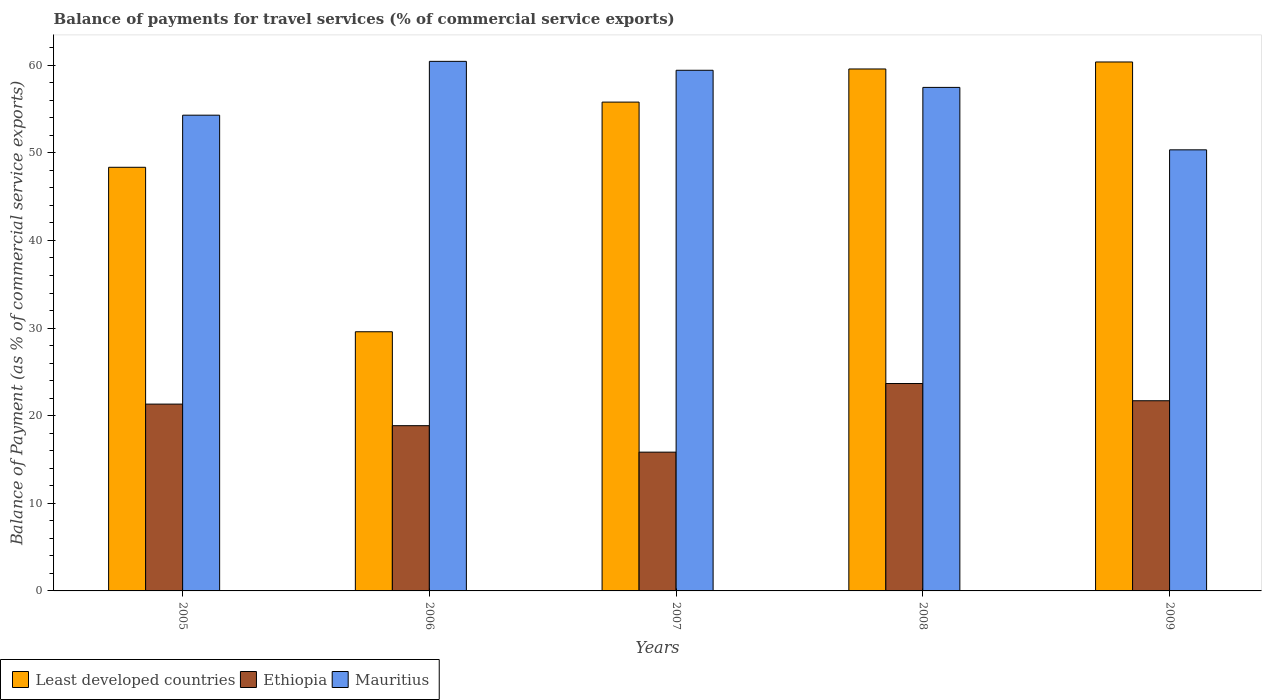How many different coloured bars are there?
Ensure brevity in your answer.  3. How many groups of bars are there?
Your answer should be very brief. 5. Are the number of bars on each tick of the X-axis equal?
Offer a very short reply. Yes. How many bars are there on the 2nd tick from the right?
Ensure brevity in your answer.  3. What is the label of the 2nd group of bars from the left?
Provide a short and direct response. 2006. In how many cases, is the number of bars for a given year not equal to the number of legend labels?
Offer a terse response. 0. What is the balance of payments for travel services in Least developed countries in 2008?
Provide a succinct answer. 59.57. Across all years, what is the maximum balance of payments for travel services in Least developed countries?
Give a very brief answer. 60.37. Across all years, what is the minimum balance of payments for travel services in Mauritius?
Make the answer very short. 50.34. In which year was the balance of payments for travel services in Least developed countries maximum?
Your answer should be compact. 2009. What is the total balance of payments for travel services in Mauritius in the graph?
Make the answer very short. 281.98. What is the difference between the balance of payments for travel services in Least developed countries in 2005 and that in 2008?
Keep it short and to the point. -11.22. What is the difference between the balance of payments for travel services in Least developed countries in 2007 and the balance of payments for travel services in Ethiopia in 2008?
Offer a terse response. 32.12. What is the average balance of payments for travel services in Ethiopia per year?
Offer a very short reply. 20.28. In the year 2009, what is the difference between the balance of payments for travel services in Ethiopia and balance of payments for travel services in Least developed countries?
Your answer should be very brief. -38.67. What is the ratio of the balance of payments for travel services in Ethiopia in 2008 to that in 2009?
Your answer should be very brief. 1.09. Is the difference between the balance of payments for travel services in Ethiopia in 2005 and 2009 greater than the difference between the balance of payments for travel services in Least developed countries in 2005 and 2009?
Give a very brief answer. Yes. What is the difference between the highest and the second highest balance of payments for travel services in Ethiopia?
Ensure brevity in your answer.  1.97. What is the difference between the highest and the lowest balance of payments for travel services in Ethiopia?
Keep it short and to the point. 7.83. Is the sum of the balance of payments for travel services in Least developed countries in 2005 and 2007 greater than the maximum balance of payments for travel services in Mauritius across all years?
Make the answer very short. Yes. What does the 3rd bar from the left in 2005 represents?
Offer a terse response. Mauritius. What does the 1st bar from the right in 2006 represents?
Make the answer very short. Mauritius. How many bars are there?
Keep it short and to the point. 15. How many years are there in the graph?
Your answer should be very brief. 5. Does the graph contain grids?
Ensure brevity in your answer.  No. Where does the legend appear in the graph?
Provide a succinct answer. Bottom left. How many legend labels are there?
Make the answer very short. 3. How are the legend labels stacked?
Provide a succinct answer. Horizontal. What is the title of the graph?
Offer a very short reply. Balance of payments for travel services (% of commercial service exports). What is the label or title of the Y-axis?
Your response must be concise. Balance of Payment (as % of commercial service exports). What is the Balance of Payment (as % of commercial service exports) in Least developed countries in 2005?
Ensure brevity in your answer.  48.35. What is the Balance of Payment (as % of commercial service exports) of Ethiopia in 2005?
Ensure brevity in your answer.  21.32. What is the Balance of Payment (as % of commercial service exports) of Mauritius in 2005?
Give a very brief answer. 54.3. What is the Balance of Payment (as % of commercial service exports) of Least developed countries in 2006?
Offer a very short reply. 29.58. What is the Balance of Payment (as % of commercial service exports) in Ethiopia in 2006?
Offer a very short reply. 18.86. What is the Balance of Payment (as % of commercial service exports) of Mauritius in 2006?
Provide a succinct answer. 60.44. What is the Balance of Payment (as % of commercial service exports) in Least developed countries in 2007?
Provide a succinct answer. 55.79. What is the Balance of Payment (as % of commercial service exports) of Ethiopia in 2007?
Your answer should be compact. 15.84. What is the Balance of Payment (as % of commercial service exports) of Mauritius in 2007?
Offer a very short reply. 59.42. What is the Balance of Payment (as % of commercial service exports) of Least developed countries in 2008?
Keep it short and to the point. 59.57. What is the Balance of Payment (as % of commercial service exports) in Ethiopia in 2008?
Ensure brevity in your answer.  23.67. What is the Balance of Payment (as % of commercial service exports) of Mauritius in 2008?
Provide a succinct answer. 57.47. What is the Balance of Payment (as % of commercial service exports) of Least developed countries in 2009?
Keep it short and to the point. 60.37. What is the Balance of Payment (as % of commercial service exports) of Ethiopia in 2009?
Ensure brevity in your answer.  21.71. What is the Balance of Payment (as % of commercial service exports) in Mauritius in 2009?
Offer a terse response. 50.34. Across all years, what is the maximum Balance of Payment (as % of commercial service exports) in Least developed countries?
Your response must be concise. 60.37. Across all years, what is the maximum Balance of Payment (as % of commercial service exports) in Ethiopia?
Provide a succinct answer. 23.67. Across all years, what is the maximum Balance of Payment (as % of commercial service exports) in Mauritius?
Your answer should be very brief. 60.44. Across all years, what is the minimum Balance of Payment (as % of commercial service exports) of Least developed countries?
Provide a short and direct response. 29.58. Across all years, what is the minimum Balance of Payment (as % of commercial service exports) in Ethiopia?
Keep it short and to the point. 15.84. Across all years, what is the minimum Balance of Payment (as % of commercial service exports) of Mauritius?
Make the answer very short. 50.34. What is the total Balance of Payment (as % of commercial service exports) of Least developed countries in the graph?
Keep it short and to the point. 253.67. What is the total Balance of Payment (as % of commercial service exports) of Ethiopia in the graph?
Your response must be concise. 101.4. What is the total Balance of Payment (as % of commercial service exports) in Mauritius in the graph?
Keep it short and to the point. 281.98. What is the difference between the Balance of Payment (as % of commercial service exports) in Least developed countries in 2005 and that in 2006?
Your answer should be very brief. 18.77. What is the difference between the Balance of Payment (as % of commercial service exports) in Ethiopia in 2005 and that in 2006?
Make the answer very short. 2.46. What is the difference between the Balance of Payment (as % of commercial service exports) of Mauritius in 2005 and that in 2006?
Give a very brief answer. -6.14. What is the difference between the Balance of Payment (as % of commercial service exports) in Least developed countries in 2005 and that in 2007?
Offer a very short reply. -7.44. What is the difference between the Balance of Payment (as % of commercial service exports) in Ethiopia in 2005 and that in 2007?
Offer a terse response. 5.48. What is the difference between the Balance of Payment (as % of commercial service exports) in Mauritius in 2005 and that in 2007?
Give a very brief answer. -5.13. What is the difference between the Balance of Payment (as % of commercial service exports) of Least developed countries in 2005 and that in 2008?
Make the answer very short. -11.22. What is the difference between the Balance of Payment (as % of commercial service exports) of Ethiopia in 2005 and that in 2008?
Ensure brevity in your answer.  -2.35. What is the difference between the Balance of Payment (as % of commercial service exports) of Mauritius in 2005 and that in 2008?
Make the answer very short. -3.17. What is the difference between the Balance of Payment (as % of commercial service exports) in Least developed countries in 2005 and that in 2009?
Your answer should be very brief. -12.02. What is the difference between the Balance of Payment (as % of commercial service exports) in Ethiopia in 2005 and that in 2009?
Make the answer very short. -0.38. What is the difference between the Balance of Payment (as % of commercial service exports) of Mauritius in 2005 and that in 2009?
Make the answer very short. 3.95. What is the difference between the Balance of Payment (as % of commercial service exports) of Least developed countries in 2006 and that in 2007?
Give a very brief answer. -26.21. What is the difference between the Balance of Payment (as % of commercial service exports) of Ethiopia in 2006 and that in 2007?
Your response must be concise. 3.02. What is the difference between the Balance of Payment (as % of commercial service exports) of Mauritius in 2006 and that in 2007?
Ensure brevity in your answer.  1.02. What is the difference between the Balance of Payment (as % of commercial service exports) of Least developed countries in 2006 and that in 2008?
Offer a terse response. -29.99. What is the difference between the Balance of Payment (as % of commercial service exports) in Ethiopia in 2006 and that in 2008?
Offer a terse response. -4.81. What is the difference between the Balance of Payment (as % of commercial service exports) in Mauritius in 2006 and that in 2008?
Offer a terse response. 2.97. What is the difference between the Balance of Payment (as % of commercial service exports) of Least developed countries in 2006 and that in 2009?
Make the answer very short. -30.79. What is the difference between the Balance of Payment (as % of commercial service exports) of Ethiopia in 2006 and that in 2009?
Ensure brevity in your answer.  -2.85. What is the difference between the Balance of Payment (as % of commercial service exports) of Mauritius in 2006 and that in 2009?
Give a very brief answer. 10.1. What is the difference between the Balance of Payment (as % of commercial service exports) of Least developed countries in 2007 and that in 2008?
Your answer should be compact. -3.78. What is the difference between the Balance of Payment (as % of commercial service exports) in Ethiopia in 2007 and that in 2008?
Provide a succinct answer. -7.83. What is the difference between the Balance of Payment (as % of commercial service exports) of Mauritius in 2007 and that in 2008?
Your answer should be compact. 1.95. What is the difference between the Balance of Payment (as % of commercial service exports) of Least developed countries in 2007 and that in 2009?
Make the answer very short. -4.58. What is the difference between the Balance of Payment (as % of commercial service exports) of Ethiopia in 2007 and that in 2009?
Provide a succinct answer. -5.87. What is the difference between the Balance of Payment (as % of commercial service exports) in Mauritius in 2007 and that in 2009?
Give a very brief answer. 9.08. What is the difference between the Balance of Payment (as % of commercial service exports) in Least developed countries in 2008 and that in 2009?
Make the answer very short. -0.8. What is the difference between the Balance of Payment (as % of commercial service exports) in Ethiopia in 2008 and that in 2009?
Your response must be concise. 1.97. What is the difference between the Balance of Payment (as % of commercial service exports) of Mauritius in 2008 and that in 2009?
Your answer should be very brief. 7.13. What is the difference between the Balance of Payment (as % of commercial service exports) in Least developed countries in 2005 and the Balance of Payment (as % of commercial service exports) in Ethiopia in 2006?
Your answer should be very brief. 29.49. What is the difference between the Balance of Payment (as % of commercial service exports) of Least developed countries in 2005 and the Balance of Payment (as % of commercial service exports) of Mauritius in 2006?
Your response must be concise. -12.09. What is the difference between the Balance of Payment (as % of commercial service exports) in Ethiopia in 2005 and the Balance of Payment (as % of commercial service exports) in Mauritius in 2006?
Ensure brevity in your answer.  -39.12. What is the difference between the Balance of Payment (as % of commercial service exports) of Least developed countries in 2005 and the Balance of Payment (as % of commercial service exports) of Ethiopia in 2007?
Your response must be concise. 32.51. What is the difference between the Balance of Payment (as % of commercial service exports) in Least developed countries in 2005 and the Balance of Payment (as % of commercial service exports) in Mauritius in 2007?
Your answer should be very brief. -11.07. What is the difference between the Balance of Payment (as % of commercial service exports) in Ethiopia in 2005 and the Balance of Payment (as % of commercial service exports) in Mauritius in 2007?
Your answer should be very brief. -38.1. What is the difference between the Balance of Payment (as % of commercial service exports) in Least developed countries in 2005 and the Balance of Payment (as % of commercial service exports) in Ethiopia in 2008?
Give a very brief answer. 24.68. What is the difference between the Balance of Payment (as % of commercial service exports) in Least developed countries in 2005 and the Balance of Payment (as % of commercial service exports) in Mauritius in 2008?
Give a very brief answer. -9.12. What is the difference between the Balance of Payment (as % of commercial service exports) of Ethiopia in 2005 and the Balance of Payment (as % of commercial service exports) of Mauritius in 2008?
Keep it short and to the point. -36.15. What is the difference between the Balance of Payment (as % of commercial service exports) in Least developed countries in 2005 and the Balance of Payment (as % of commercial service exports) in Ethiopia in 2009?
Offer a very short reply. 26.65. What is the difference between the Balance of Payment (as % of commercial service exports) in Least developed countries in 2005 and the Balance of Payment (as % of commercial service exports) in Mauritius in 2009?
Provide a short and direct response. -1.99. What is the difference between the Balance of Payment (as % of commercial service exports) in Ethiopia in 2005 and the Balance of Payment (as % of commercial service exports) in Mauritius in 2009?
Keep it short and to the point. -29.02. What is the difference between the Balance of Payment (as % of commercial service exports) in Least developed countries in 2006 and the Balance of Payment (as % of commercial service exports) in Ethiopia in 2007?
Your answer should be very brief. 13.74. What is the difference between the Balance of Payment (as % of commercial service exports) of Least developed countries in 2006 and the Balance of Payment (as % of commercial service exports) of Mauritius in 2007?
Your response must be concise. -29.84. What is the difference between the Balance of Payment (as % of commercial service exports) in Ethiopia in 2006 and the Balance of Payment (as % of commercial service exports) in Mauritius in 2007?
Keep it short and to the point. -40.56. What is the difference between the Balance of Payment (as % of commercial service exports) in Least developed countries in 2006 and the Balance of Payment (as % of commercial service exports) in Ethiopia in 2008?
Keep it short and to the point. 5.91. What is the difference between the Balance of Payment (as % of commercial service exports) of Least developed countries in 2006 and the Balance of Payment (as % of commercial service exports) of Mauritius in 2008?
Your response must be concise. -27.89. What is the difference between the Balance of Payment (as % of commercial service exports) of Ethiopia in 2006 and the Balance of Payment (as % of commercial service exports) of Mauritius in 2008?
Keep it short and to the point. -38.61. What is the difference between the Balance of Payment (as % of commercial service exports) of Least developed countries in 2006 and the Balance of Payment (as % of commercial service exports) of Ethiopia in 2009?
Provide a succinct answer. 7.87. What is the difference between the Balance of Payment (as % of commercial service exports) of Least developed countries in 2006 and the Balance of Payment (as % of commercial service exports) of Mauritius in 2009?
Provide a succinct answer. -20.76. What is the difference between the Balance of Payment (as % of commercial service exports) in Ethiopia in 2006 and the Balance of Payment (as % of commercial service exports) in Mauritius in 2009?
Give a very brief answer. -31.48. What is the difference between the Balance of Payment (as % of commercial service exports) in Least developed countries in 2007 and the Balance of Payment (as % of commercial service exports) in Ethiopia in 2008?
Give a very brief answer. 32.12. What is the difference between the Balance of Payment (as % of commercial service exports) in Least developed countries in 2007 and the Balance of Payment (as % of commercial service exports) in Mauritius in 2008?
Offer a terse response. -1.68. What is the difference between the Balance of Payment (as % of commercial service exports) in Ethiopia in 2007 and the Balance of Payment (as % of commercial service exports) in Mauritius in 2008?
Your response must be concise. -41.63. What is the difference between the Balance of Payment (as % of commercial service exports) of Least developed countries in 2007 and the Balance of Payment (as % of commercial service exports) of Ethiopia in 2009?
Provide a succinct answer. 34.09. What is the difference between the Balance of Payment (as % of commercial service exports) in Least developed countries in 2007 and the Balance of Payment (as % of commercial service exports) in Mauritius in 2009?
Make the answer very short. 5.45. What is the difference between the Balance of Payment (as % of commercial service exports) in Ethiopia in 2007 and the Balance of Payment (as % of commercial service exports) in Mauritius in 2009?
Provide a succinct answer. -34.5. What is the difference between the Balance of Payment (as % of commercial service exports) in Least developed countries in 2008 and the Balance of Payment (as % of commercial service exports) in Ethiopia in 2009?
Offer a very short reply. 37.87. What is the difference between the Balance of Payment (as % of commercial service exports) in Least developed countries in 2008 and the Balance of Payment (as % of commercial service exports) in Mauritius in 2009?
Offer a terse response. 9.23. What is the difference between the Balance of Payment (as % of commercial service exports) in Ethiopia in 2008 and the Balance of Payment (as % of commercial service exports) in Mauritius in 2009?
Provide a short and direct response. -26.67. What is the average Balance of Payment (as % of commercial service exports) in Least developed countries per year?
Offer a very short reply. 50.73. What is the average Balance of Payment (as % of commercial service exports) in Ethiopia per year?
Keep it short and to the point. 20.28. What is the average Balance of Payment (as % of commercial service exports) of Mauritius per year?
Your answer should be compact. 56.4. In the year 2005, what is the difference between the Balance of Payment (as % of commercial service exports) in Least developed countries and Balance of Payment (as % of commercial service exports) in Ethiopia?
Your answer should be compact. 27.03. In the year 2005, what is the difference between the Balance of Payment (as % of commercial service exports) in Least developed countries and Balance of Payment (as % of commercial service exports) in Mauritius?
Keep it short and to the point. -5.95. In the year 2005, what is the difference between the Balance of Payment (as % of commercial service exports) of Ethiopia and Balance of Payment (as % of commercial service exports) of Mauritius?
Make the answer very short. -32.98. In the year 2006, what is the difference between the Balance of Payment (as % of commercial service exports) in Least developed countries and Balance of Payment (as % of commercial service exports) in Ethiopia?
Make the answer very short. 10.72. In the year 2006, what is the difference between the Balance of Payment (as % of commercial service exports) in Least developed countries and Balance of Payment (as % of commercial service exports) in Mauritius?
Offer a terse response. -30.86. In the year 2006, what is the difference between the Balance of Payment (as % of commercial service exports) of Ethiopia and Balance of Payment (as % of commercial service exports) of Mauritius?
Make the answer very short. -41.58. In the year 2007, what is the difference between the Balance of Payment (as % of commercial service exports) of Least developed countries and Balance of Payment (as % of commercial service exports) of Ethiopia?
Make the answer very short. 39.95. In the year 2007, what is the difference between the Balance of Payment (as % of commercial service exports) in Least developed countries and Balance of Payment (as % of commercial service exports) in Mauritius?
Keep it short and to the point. -3.63. In the year 2007, what is the difference between the Balance of Payment (as % of commercial service exports) of Ethiopia and Balance of Payment (as % of commercial service exports) of Mauritius?
Make the answer very short. -43.58. In the year 2008, what is the difference between the Balance of Payment (as % of commercial service exports) in Least developed countries and Balance of Payment (as % of commercial service exports) in Ethiopia?
Make the answer very short. 35.9. In the year 2008, what is the difference between the Balance of Payment (as % of commercial service exports) of Least developed countries and Balance of Payment (as % of commercial service exports) of Mauritius?
Keep it short and to the point. 2.1. In the year 2008, what is the difference between the Balance of Payment (as % of commercial service exports) in Ethiopia and Balance of Payment (as % of commercial service exports) in Mauritius?
Your answer should be compact. -33.8. In the year 2009, what is the difference between the Balance of Payment (as % of commercial service exports) of Least developed countries and Balance of Payment (as % of commercial service exports) of Ethiopia?
Provide a succinct answer. 38.67. In the year 2009, what is the difference between the Balance of Payment (as % of commercial service exports) of Least developed countries and Balance of Payment (as % of commercial service exports) of Mauritius?
Provide a succinct answer. 10.03. In the year 2009, what is the difference between the Balance of Payment (as % of commercial service exports) in Ethiopia and Balance of Payment (as % of commercial service exports) in Mauritius?
Provide a succinct answer. -28.64. What is the ratio of the Balance of Payment (as % of commercial service exports) in Least developed countries in 2005 to that in 2006?
Offer a terse response. 1.63. What is the ratio of the Balance of Payment (as % of commercial service exports) in Ethiopia in 2005 to that in 2006?
Keep it short and to the point. 1.13. What is the ratio of the Balance of Payment (as % of commercial service exports) in Mauritius in 2005 to that in 2006?
Your response must be concise. 0.9. What is the ratio of the Balance of Payment (as % of commercial service exports) of Least developed countries in 2005 to that in 2007?
Your answer should be compact. 0.87. What is the ratio of the Balance of Payment (as % of commercial service exports) in Ethiopia in 2005 to that in 2007?
Ensure brevity in your answer.  1.35. What is the ratio of the Balance of Payment (as % of commercial service exports) of Mauritius in 2005 to that in 2007?
Ensure brevity in your answer.  0.91. What is the ratio of the Balance of Payment (as % of commercial service exports) in Least developed countries in 2005 to that in 2008?
Offer a very short reply. 0.81. What is the ratio of the Balance of Payment (as % of commercial service exports) of Ethiopia in 2005 to that in 2008?
Offer a very short reply. 0.9. What is the ratio of the Balance of Payment (as % of commercial service exports) in Mauritius in 2005 to that in 2008?
Your response must be concise. 0.94. What is the ratio of the Balance of Payment (as % of commercial service exports) in Least developed countries in 2005 to that in 2009?
Your answer should be very brief. 0.8. What is the ratio of the Balance of Payment (as % of commercial service exports) of Ethiopia in 2005 to that in 2009?
Your response must be concise. 0.98. What is the ratio of the Balance of Payment (as % of commercial service exports) of Mauritius in 2005 to that in 2009?
Keep it short and to the point. 1.08. What is the ratio of the Balance of Payment (as % of commercial service exports) in Least developed countries in 2006 to that in 2007?
Ensure brevity in your answer.  0.53. What is the ratio of the Balance of Payment (as % of commercial service exports) of Ethiopia in 2006 to that in 2007?
Make the answer very short. 1.19. What is the ratio of the Balance of Payment (as % of commercial service exports) in Mauritius in 2006 to that in 2007?
Your answer should be very brief. 1.02. What is the ratio of the Balance of Payment (as % of commercial service exports) in Least developed countries in 2006 to that in 2008?
Make the answer very short. 0.5. What is the ratio of the Balance of Payment (as % of commercial service exports) of Ethiopia in 2006 to that in 2008?
Offer a terse response. 0.8. What is the ratio of the Balance of Payment (as % of commercial service exports) in Mauritius in 2006 to that in 2008?
Keep it short and to the point. 1.05. What is the ratio of the Balance of Payment (as % of commercial service exports) of Least developed countries in 2006 to that in 2009?
Give a very brief answer. 0.49. What is the ratio of the Balance of Payment (as % of commercial service exports) in Ethiopia in 2006 to that in 2009?
Your answer should be compact. 0.87. What is the ratio of the Balance of Payment (as % of commercial service exports) of Mauritius in 2006 to that in 2009?
Provide a succinct answer. 1.2. What is the ratio of the Balance of Payment (as % of commercial service exports) in Least developed countries in 2007 to that in 2008?
Keep it short and to the point. 0.94. What is the ratio of the Balance of Payment (as % of commercial service exports) in Ethiopia in 2007 to that in 2008?
Offer a very short reply. 0.67. What is the ratio of the Balance of Payment (as % of commercial service exports) of Mauritius in 2007 to that in 2008?
Offer a terse response. 1.03. What is the ratio of the Balance of Payment (as % of commercial service exports) of Least developed countries in 2007 to that in 2009?
Give a very brief answer. 0.92. What is the ratio of the Balance of Payment (as % of commercial service exports) in Ethiopia in 2007 to that in 2009?
Your answer should be compact. 0.73. What is the ratio of the Balance of Payment (as % of commercial service exports) of Mauritius in 2007 to that in 2009?
Offer a very short reply. 1.18. What is the ratio of the Balance of Payment (as % of commercial service exports) in Ethiopia in 2008 to that in 2009?
Keep it short and to the point. 1.09. What is the ratio of the Balance of Payment (as % of commercial service exports) of Mauritius in 2008 to that in 2009?
Provide a short and direct response. 1.14. What is the difference between the highest and the second highest Balance of Payment (as % of commercial service exports) in Least developed countries?
Make the answer very short. 0.8. What is the difference between the highest and the second highest Balance of Payment (as % of commercial service exports) of Ethiopia?
Give a very brief answer. 1.97. What is the difference between the highest and the second highest Balance of Payment (as % of commercial service exports) in Mauritius?
Offer a terse response. 1.02. What is the difference between the highest and the lowest Balance of Payment (as % of commercial service exports) of Least developed countries?
Offer a terse response. 30.79. What is the difference between the highest and the lowest Balance of Payment (as % of commercial service exports) of Ethiopia?
Provide a short and direct response. 7.83. What is the difference between the highest and the lowest Balance of Payment (as % of commercial service exports) of Mauritius?
Provide a short and direct response. 10.1. 